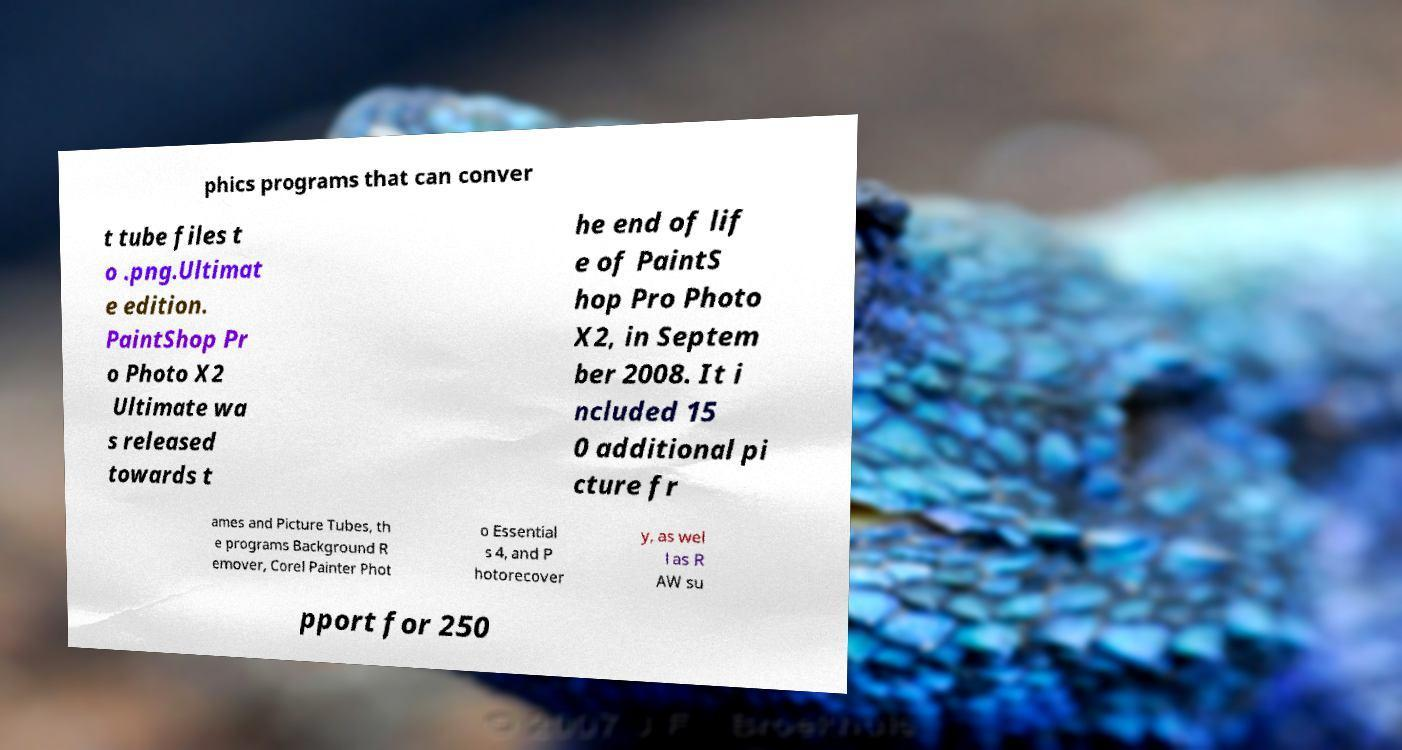Can you accurately transcribe the text from the provided image for me? phics programs that can conver t tube files t o .png.Ultimat e edition. PaintShop Pr o Photo X2 Ultimate wa s released towards t he end of lif e of PaintS hop Pro Photo X2, in Septem ber 2008. It i ncluded 15 0 additional pi cture fr ames and Picture Tubes, th e programs Background R emover, Corel Painter Phot o Essential s 4, and P hotorecover y, as wel l as R AW su pport for 250 